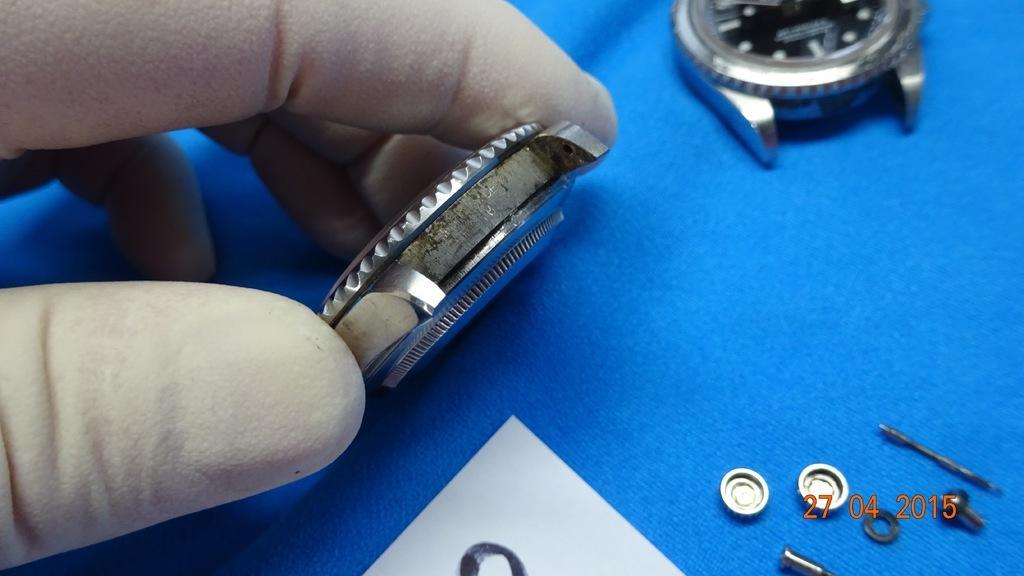Describe this image in one or two sentences. In this picture I can see the fingers of a person holding a watch lug, there are batteries, there is another watch lug and some other items on the surface, and there is a watermark on the image. 